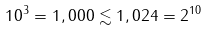Convert formula to latex. <formula><loc_0><loc_0><loc_500><loc_500>1 0 ^ { 3 } = 1 , 0 0 0 \lesssim 1 , 0 2 4 = 2 ^ { 1 0 }</formula> 